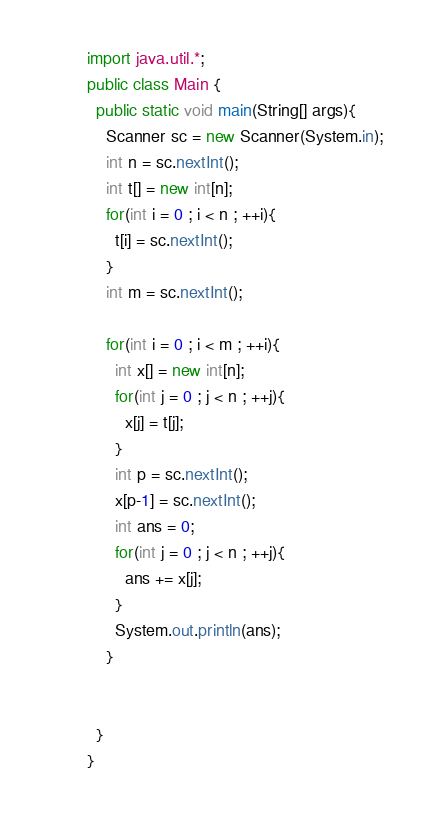Convert code to text. <code><loc_0><loc_0><loc_500><loc_500><_Java_>import java.util.*;
public class Main {
  public static void main(String[] args){
    Scanner sc = new Scanner(System.in);
    int n = sc.nextInt();
    int t[] = new int[n];
    for(int i = 0 ; i < n ; ++i){
      t[i] = sc.nextInt();
    }
    int m = sc.nextInt();
    
    for(int i = 0 ; i < m ; ++i){
      int x[] = new int[n];
      for(int j = 0 ; j < n ; ++j){
        x[j] = t[j];
      }
      int p = sc.nextInt();
      x[p-1] = sc.nextInt();
      int ans = 0;
      for(int j = 0 ; j < n ; ++j){
        ans += x[j];
      }
      System.out.println(ans);
    }
    
    
  }
}</code> 